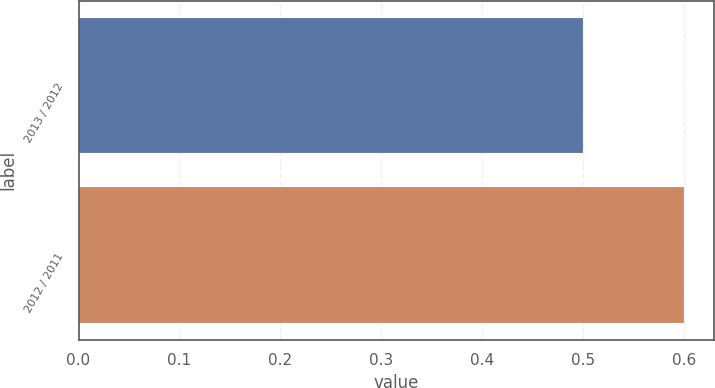Convert chart. <chart><loc_0><loc_0><loc_500><loc_500><bar_chart><fcel>2013 / 2012<fcel>2012 / 2011<nl><fcel>0.5<fcel>0.6<nl></chart> 